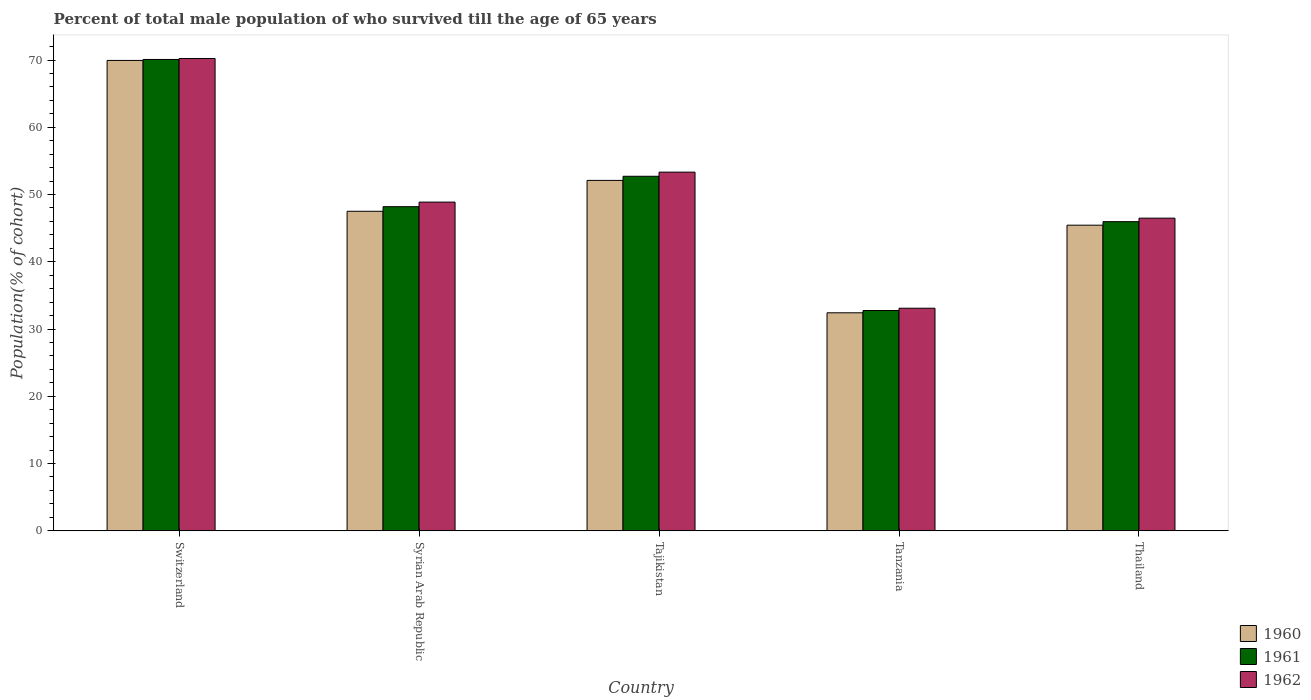How many groups of bars are there?
Make the answer very short. 5. Are the number of bars per tick equal to the number of legend labels?
Your response must be concise. Yes. Are the number of bars on each tick of the X-axis equal?
Your answer should be very brief. Yes. What is the label of the 4th group of bars from the left?
Offer a terse response. Tanzania. What is the percentage of total male population who survived till the age of 65 years in 1961 in Tajikistan?
Offer a very short reply. 52.71. Across all countries, what is the maximum percentage of total male population who survived till the age of 65 years in 1961?
Keep it short and to the point. 70.08. Across all countries, what is the minimum percentage of total male population who survived till the age of 65 years in 1961?
Make the answer very short. 32.75. In which country was the percentage of total male population who survived till the age of 65 years in 1962 maximum?
Give a very brief answer. Switzerland. In which country was the percentage of total male population who survived till the age of 65 years in 1962 minimum?
Offer a very short reply. Tanzania. What is the total percentage of total male population who survived till the age of 65 years in 1960 in the graph?
Give a very brief answer. 247.4. What is the difference between the percentage of total male population who survived till the age of 65 years in 1961 in Switzerland and that in Thailand?
Ensure brevity in your answer.  24.12. What is the difference between the percentage of total male population who survived till the age of 65 years in 1962 in Tajikistan and the percentage of total male population who survived till the age of 65 years in 1960 in Switzerland?
Your answer should be compact. -16.61. What is the average percentage of total male population who survived till the age of 65 years in 1962 per country?
Keep it short and to the point. 50.4. What is the difference between the percentage of total male population who survived till the age of 65 years of/in 1962 and percentage of total male population who survived till the age of 65 years of/in 1960 in Syrian Arab Republic?
Your answer should be compact. 1.36. In how many countries, is the percentage of total male population who survived till the age of 65 years in 1961 greater than 6 %?
Your answer should be compact. 5. What is the ratio of the percentage of total male population who survived till the age of 65 years in 1961 in Tanzania to that in Thailand?
Offer a very short reply. 0.71. Is the percentage of total male population who survived till the age of 65 years in 1962 in Switzerland less than that in Tajikistan?
Keep it short and to the point. No. Is the difference between the percentage of total male population who survived till the age of 65 years in 1962 in Tanzania and Thailand greater than the difference between the percentage of total male population who survived till the age of 65 years in 1960 in Tanzania and Thailand?
Your answer should be compact. No. What is the difference between the highest and the second highest percentage of total male population who survived till the age of 65 years in 1962?
Provide a succinct answer. -4.45. What is the difference between the highest and the lowest percentage of total male population who survived till the age of 65 years in 1962?
Your answer should be compact. 37.13. Is the sum of the percentage of total male population who survived till the age of 65 years in 1962 in Switzerland and Tanzania greater than the maximum percentage of total male population who survived till the age of 65 years in 1960 across all countries?
Your response must be concise. Yes. How many bars are there?
Your answer should be very brief. 15. What is the difference between two consecutive major ticks on the Y-axis?
Provide a short and direct response. 10. Are the values on the major ticks of Y-axis written in scientific E-notation?
Provide a succinct answer. No. Does the graph contain grids?
Your answer should be compact. No. How many legend labels are there?
Provide a succinct answer. 3. What is the title of the graph?
Offer a terse response. Percent of total male population of who survived till the age of 65 years. What is the label or title of the Y-axis?
Your answer should be compact. Population(% of cohort). What is the Population(% of cohort) in 1960 in Switzerland?
Make the answer very short. 69.94. What is the Population(% of cohort) in 1961 in Switzerland?
Provide a succinct answer. 70.08. What is the Population(% of cohort) of 1962 in Switzerland?
Offer a terse response. 70.22. What is the Population(% of cohort) of 1960 in Syrian Arab Republic?
Offer a very short reply. 47.51. What is the Population(% of cohort) of 1961 in Syrian Arab Republic?
Provide a succinct answer. 48.19. What is the Population(% of cohort) of 1962 in Syrian Arab Republic?
Your answer should be compact. 48.87. What is the Population(% of cohort) in 1960 in Tajikistan?
Give a very brief answer. 52.1. What is the Population(% of cohort) of 1961 in Tajikistan?
Provide a succinct answer. 52.71. What is the Population(% of cohort) of 1962 in Tajikistan?
Offer a terse response. 53.33. What is the Population(% of cohort) in 1960 in Tanzania?
Provide a succinct answer. 32.41. What is the Population(% of cohort) of 1961 in Tanzania?
Provide a succinct answer. 32.75. What is the Population(% of cohort) of 1962 in Tanzania?
Your response must be concise. 33.09. What is the Population(% of cohort) in 1960 in Thailand?
Offer a terse response. 45.44. What is the Population(% of cohort) of 1961 in Thailand?
Offer a very short reply. 45.96. What is the Population(% of cohort) of 1962 in Thailand?
Your response must be concise. 46.48. Across all countries, what is the maximum Population(% of cohort) of 1960?
Keep it short and to the point. 69.94. Across all countries, what is the maximum Population(% of cohort) of 1961?
Make the answer very short. 70.08. Across all countries, what is the maximum Population(% of cohort) of 1962?
Your answer should be compact. 70.22. Across all countries, what is the minimum Population(% of cohort) in 1960?
Provide a succinct answer. 32.41. Across all countries, what is the minimum Population(% of cohort) of 1961?
Keep it short and to the point. 32.75. Across all countries, what is the minimum Population(% of cohort) in 1962?
Ensure brevity in your answer.  33.09. What is the total Population(% of cohort) in 1960 in the graph?
Provide a short and direct response. 247.4. What is the total Population(% of cohort) in 1961 in the graph?
Keep it short and to the point. 249.7. What is the total Population(% of cohort) of 1962 in the graph?
Offer a terse response. 252. What is the difference between the Population(% of cohort) of 1960 in Switzerland and that in Syrian Arab Republic?
Keep it short and to the point. 22.43. What is the difference between the Population(% of cohort) in 1961 in Switzerland and that in Syrian Arab Republic?
Ensure brevity in your answer.  21.89. What is the difference between the Population(% of cohort) in 1962 in Switzerland and that in Syrian Arab Republic?
Make the answer very short. 21.35. What is the difference between the Population(% of cohort) in 1960 in Switzerland and that in Tajikistan?
Give a very brief answer. 17.84. What is the difference between the Population(% of cohort) in 1961 in Switzerland and that in Tajikistan?
Provide a succinct answer. 17.37. What is the difference between the Population(% of cohort) of 1962 in Switzerland and that in Tajikistan?
Provide a succinct answer. 16.9. What is the difference between the Population(% of cohort) of 1960 in Switzerland and that in Tanzania?
Offer a terse response. 37.52. What is the difference between the Population(% of cohort) in 1961 in Switzerland and that in Tanzania?
Offer a very short reply. 37.33. What is the difference between the Population(% of cohort) in 1962 in Switzerland and that in Tanzania?
Your answer should be very brief. 37.13. What is the difference between the Population(% of cohort) in 1960 in Switzerland and that in Thailand?
Make the answer very short. 24.5. What is the difference between the Population(% of cohort) in 1961 in Switzerland and that in Thailand?
Make the answer very short. 24.12. What is the difference between the Population(% of cohort) in 1962 in Switzerland and that in Thailand?
Make the answer very short. 23.74. What is the difference between the Population(% of cohort) in 1960 in Syrian Arab Republic and that in Tajikistan?
Keep it short and to the point. -4.59. What is the difference between the Population(% of cohort) of 1961 in Syrian Arab Republic and that in Tajikistan?
Offer a very short reply. -4.52. What is the difference between the Population(% of cohort) of 1962 in Syrian Arab Republic and that in Tajikistan?
Provide a short and direct response. -4.45. What is the difference between the Population(% of cohort) in 1960 in Syrian Arab Republic and that in Tanzania?
Keep it short and to the point. 15.1. What is the difference between the Population(% of cohort) of 1961 in Syrian Arab Republic and that in Tanzania?
Ensure brevity in your answer.  15.44. What is the difference between the Population(% of cohort) in 1962 in Syrian Arab Republic and that in Tanzania?
Offer a terse response. 15.78. What is the difference between the Population(% of cohort) of 1960 in Syrian Arab Republic and that in Thailand?
Give a very brief answer. 2.07. What is the difference between the Population(% of cohort) of 1961 in Syrian Arab Republic and that in Thailand?
Offer a very short reply. 2.23. What is the difference between the Population(% of cohort) of 1962 in Syrian Arab Republic and that in Thailand?
Give a very brief answer. 2.39. What is the difference between the Population(% of cohort) of 1960 in Tajikistan and that in Tanzania?
Offer a very short reply. 19.68. What is the difference between the Population(% of cohort) in 1961 in Tajikistan and that in Tanzania?
Make the answer very short. 19.96. What is the difference between the Population(% of cohort) in 1962 in Tajikistan and that in Tanzania?
Your response must be concise. 20.24. What is the difference between the Population(% of cohort) in 1960 in Tajikistan and that in Thailand?
Give a very brief answer. 6.66. What is the difference between the Population(% of cohort) in 1961 in Tajikistan and that in Thailand?
Provide a short and direct response. 6.75. What is the difference between the Population(% of cohort) of 1962 in Tajikistan and that in Thailand?
Make the answer very short. 6.84. What is the difference between the Population(% of cohort) of 1960 in Tanzania and that in Thailand?
Offer a terse response. -13.03. What is the difference between the Population(% of cohort) of 1961 in Tanzania and that in Thailand?
Offer a terse response. -13.21. What is the difference between the Population(% of cohort) of 1962 in Tanzania and that in Thailand?
Make the answer very short. -13.39. What is the difference between the Population(% of cohort) in 1960 in Switzerland and the Population(% of cohort) in 1961 in Syrian Arab Republic?
Give a very brief answer. 21.75. What is the difference between the Population(% of cohort) in 1960 in Switzerland and the Population(% of cohort) in 1962 in Syrian Arab Republic?
Provide a succinct answer. 21.06. What is the difference between the Population(% of cohort) of 1961 in Switzerland and the Population(% of cohort) of 1962 in Syrian Arab Republic?
Make the answer very short. 21.21. What is the difference between the Population(% of cohort) of 1960 in Switzerland and the Population(% of cohort) of 1961 in Tajikistan?
Your response must be concise. 17.22. What is the difference between the Population(% of cohort) of 1960 in Switzerland and the Population(% of cohort) of 1962 in Tajikistan?
Provide a short and direct response. 16.61. What is the difference between the Population(% of cohort) of 1961 in Switzerland and the Population(% of cohort) of 1962 in Tajikistan?
Your answer should be compact. 16.75. What is the difference between the Population(% of cohort) in 1960 in Switzerland and the Population(% of cohort) in 1961 in Tanzania?
Keep it short and to the point. 37.18. What is the difference between the Population(% of cohort) of 1960 in Switzerland and the Population(% of cohort) of 1962 in Tanzania?
Your answer should be compact. 36.85. What is the difference between the Population(% of cohort) of 1961 in Switzerland and the Population(% of cohort) of 1962 in Tanzania?
Your answer should be compact. 36.99. What is the difference between the Population(% of cohort) of 1960 in Switzerland and the Population(% of cohort) of 1961 in Thailand?
Offer a terse response. 23.97. What is the difference between the Population(% of cohort) of 1960 in Switzerland and the Population(% of cohort) of 1962 in Thailand?
Offer a terse response. 23.45. What is the difference between the Population(% of cohort) of 1961 in Switzerland and the Population(% of cohort) of 1962 in Thailand?
Offer a terse response. 23.6. What is the difference between the Population(% of cohort) of 1960 in Syrian Arab Republic and the Population(% of cohort) of 1961 in Tajikistan?
Provide a short and direct response. -5.2. What is the difference between the Population(% of cohort) in 1960 in Syrian Arab Republic and the Population(% of cohort) in 1962 in Tajikistan?
Offer a very short reply. -5.82. What is the difference between the Population(% of cohort) of 1961 in Syrian Arab Republic and the Population(% of cohort) of 1962 in Tajikistan?
Provide a short and direct response. -5.14. What is the difference between the Population(% of cohort) of 1960 in Syrian Arab Republic and the Population(% of cohort) of 1961 in Tanzania?
Your answer should be compact. 14.76. What is the difference between the Population(% of cohort) of 1960 in Syrian Arab Republic and the Population(% of cohort) of 1962 in Tanzania?
Make the answer very short. 14.42. What is the difference between the Population(% of cohort) in 1961 in Syrian Arab Republic and the Population(% of cohort) in 1962 in Tanzania?
Offer a very short reply. 15.1. What is the difference between the Population(% of cohort) in 1960 in Syrian Arab Republic and the Population(% of cohort) in 1961 in Thailand?
Provide a succinct answer. 1.55. What is the difference between the Population(% of cohort) of 1960 in Syrian Arab Republic and the Population(% of cohort) of 1962 in Thailand?
Offer a very short reply. 1.02. What is the difference between the Population(% of cohort) in 1961 in Syrian Arab Republic and the Population(% of cohort) in 1962 in Thailand?
Keep it short and to the point. 1.71. What is the difference between the Population(% of cohort) in 1960 in Tajikistan and the Population(% of cohort) in 1961 in Tanzania?
Ensure brevity in your answer.  19.35. What is the difference between the Population(% of cohort) of 1960 in Tajikistan and the Population(% of cohort) of 1962 in Tanzania?
Keep it short and to the point. 19.01. What is the difference between the Population(% of cohort) of 1961 in Tajikistan and the Population(% of cohort) of 1962 in Tanzania?
Your answer should be very brief. 19.62. What is the difference between the Population(% of cohort) in 1960 in Tajikistan and the Population(% of cohort) in 1961 in Thailand?
Keep it short and to the point. 6.14. What is the difference between the Population(% of cohort) in 1960 in Tajikistan and the Population(% of cohort) in 1962 in Thailand?
Your answer should be very brief. 5.61. What is the difference between the Population(% of cohort) in 1961 in Tajikistan and the Population(% of cohort) in 1962 in Thailand?
Make the answer very short. 6.23. What is the difference between the Population(% of cohort) of 1960 in Tanzania and the Population(% of cohort) of 1961 in Thailand?
Provide a short and direct response. -13.55. What is the difference between the Population(% of cohort) in 1960 in Tanzania and the Population(% of cohort) in 1962 in Thailand?
Offer a terse response. -14.07. What is the difference between the Population(% of cohort) of 1961 in Tanzania and the Population(% of cohort) of 1962 in Thailand?
Your response must be concise. -13.73. What is the average Population(% of cohort) in 1960 per country?
Keep it short and to the point. 49.48. What is the average Population(% of cohort) of 1961 per country?
Your response must be concise. 49.94. What is the average Population(% of cohort) in 1962 per country?
Give a very brief answer. 50.4. What is the difference between the Population(% of cohort) of 1960 and Population(% of cohort) of 1961 in Switzerland?
Give a very brief answer. -0.14. What is the difference between the Population(% of cohort) in 1960 and Population(% of cohort) in 1962 in Switzerland?
Offer a terse response. -0.29. What is the difference between the Population(% of cohort) in 1961 and Population(% of cohort) in 1962 in Switzerland?
Your response must be concise. -0.14. What is the difference between the Population(% of cohort) in 1960 and Population(% of cohort) in 1961 in Syrian Arab Republic?
Provide a succinct answer. -0.68. What is the difference between the Population(% of cohort) of 1960 and Population(% of cohort) of 1962 in Syrian Arab Republic?
Offer a very short reply. -1.36. What is the difference between the Population(% of cohort) in 1961 and Population(% of cohort) in 1962 in Syrian Arab Republic?
Give a very brief answer. -0.68. What is the difference between the Population(% of cohort) in 1960 and Population(% of cohort) in 1961 in Tajikistan?
Give a very brief answer. -0.61. What is the difference between the Population(% of cohort) of 1960 and Population(% of cohort) of 1962 in Tajikistan?
Make the answer very short. -1.23. What is the difference between the Population(% of cohort) of 1961 and Population(% of cohort) of 1962 in Tajikistan?
Ensure brevity in your answer.  -0.61. What is the difference between the Population(% of cohort) of 1960 and Population(% of cohort) of 1961 in Tanzania?
Provide a succinct answer. -0.34. What is the difference between the Population(% of cohort) of 1960 and Population(% of cohort) of 1962 in Tanzania?
Keep it short and to the point. -0.68. What is the difference between the Population(% of cohort) in 1961 and Population(% of cohort) in 1962 in Tanzania?
Keep it short and to the point. -0.34. What is the difference between the Population(% of cohort) of 1960 and Population(% of cohort) of 1961 in Thailand?
Offer a terse response. -0.52. What is the difference between the Population(% of cohort) in 1960 and Population(% of cohort) in 1962 in Thailand?
Offer a very short reply. -1.04. What is the difference between the Population(% of cohort) of 1961 and Population(% of cohort) of 1962 in Thailand?
Provide a short and direct response. -0.52. What is the ratio of the Population(% of cohort) in 1960 in Switzerland to that in Syrian Arab Republic?
Your response must be concise. 1.47. What is the ratio of the Population(% of cohort) of 1961 in Switzerland to that in Syrian Arab Republic?
Make the answer very short. 1.45. What is the ratio of the Population(% of cohort) in 1962 in Switzerland to that in Syrian Arab Republic?
Your response must be concise. 1.44. What is the ratio of the Population(% of cohort) of 1960 in Switzerland to that in Tajikistan?
Offer a very short reply. 1.34. What is the ratio of the Population(% of cohort) of 1961 in Switzerland to that in Tajikistan?
Keep it short and to the point. 1.33. What is the ratio of the Population(% of cohort) of 1962 in Switzerland to that in Tajikistan?
Offer a very short reply. 1.32. What is the ratio of the Population(% of cohort) in 1960 in Switzerland to that in Tanzania?
Provide a succinct answer. 2.16. What is the ratio of the Population(% of cohort) in 1961 in Switzerland to that in Tanzania?
Keep it short and to the point. 2.14. What is the ratio of the Population(% of cohort) of 1962 in Switzerland to that in Tanzania?
Your answer should be very brief. 2.12. What is the ratio of the Population(% of cohort) in 1960 in Switzerland to that in Thailand?
Give a very brief answer. 1.54. What is the ratio of the Population(% of cohort) of 1961 in Switzerland to that in Thailand?
Give a very brief answer. 1.52. What is the ratio of the Population(% of cohort) of 1962 in Switzerland to that in Thailand?
Provide a succinct answer. 1.51. What is the ratio of the Population(% of cohort) in 1960 in Syrian Arab Republic to that in Tajikistan?
Give a very brief answer. 0.91. What is the ratio of the Population(% of cohort) in 1961 in Syrian Arab Republic to that in Tajikistan?
Your answer should be very brief. 0.91. What is the ratio of the Population(% of cohort) in 1962 in Syrian Arab Republic to that in Tajikistan?
Provide a succinct answer. 0.92. What is the ratio of the Population(% of cohort) of 1960 in Syrian Arab Republic to that in Tanzania?
Your answer should be very brief. 1.47. What is the ratio of the Population(% of cohort) in 1961 in Syrian Arab Republic to that in Tanzania?
Provide a short and direct response. 1.47. What is the ratio of the Population(% of cohort) of 1962 in Syrian Arab Republic to that in Tanzania?
Your answer should be compact. 1.48. What is the ratio of the Population(% of cohort) of 1960 in Syrian Arab Republic to that in Thailand?
Provide a succinct answer. 1.05. What is the ratio of the Population(% of cohort) of 1961 in Syrian Arab Republic to that in Thailand?
Provide a succinct answer. 1.05. What is the ratio of the Population(% of cohort) of 1962 in Syrian Arab Republic to that in Thailand?
Offer a very short reply. 1.05. What is the ratio of the Population(% of cohort) in 1960 in Tajikistan to that in Tanzania?
Your answer should be very brief. 1.61. What is the ratio of the Population(% of cohort) in 1961 in Tajikistan to that in Tanzania?
Keep it short and to the point. 1.61. What is the ratio of the Population(% of cohort) in 1962 in Tajikistan to that in Tanzania?
Provide a succinct answer. 1.61. What is the ratio of the Population(% of cohort) of 1960 in Tajikistan to that in Thailand?
Your answer should be compact. 1.15. What is the ratio of the Population(% of cohort) in 1961 in Tajikistan to that in Thailand?
Offer a terse response. 1.15. What is the ratio of the Population(% of cohort) of 1962 in Tajikistan to that in Thailand?
Make the answer very short. 1.15. What is the ratio of the Population(% of cohort) in 1960 in Tanzania to that in Thailand?
Provide a succinct answer. 0.71. What is the ratio of the Population(% of cohort) in 1961 in Tanzania to that in Thailand?
Offer a terse response. 0.71. What is the ratio of the Population(% of cohort) in 1962 in Tanzania to that in Thailand?
Ensure brevity in your answer.  0.71. What is the difference between the highest and the second highest Population(% of cohort) of 1960?
Ensure brevity in your answer.  17.84. What is the difference between the highest and the second highest Population(% of cohort) of 1961?
Your answer should be very brief. 17.37. What is the difference between the highest and the second highest Population(% of cohort) in 1962?
Provide a succinct answer. 16.9. What is the difference between the highest and the lowest Population(% of cohort) in 1960?
Keep it short and to the point. 37.52. What is the difference between the highest and the lowest Population(% of cohort) of 1961?
Ensure brevity in your answer.  37.33. What is the difference between the highest and the lowest Population(% of cohort) in 1962?
Offer a very short reply. 37.13. 